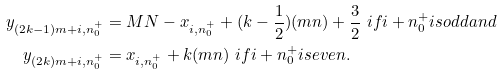<formula> <loc_0><loc_0><loc_500><loc_500>y _ { ( 2 k - 1 ) m + i , n ^ { + } _ { 0 } } & = M N - x _ { i , n ^ { + } _ { 0 } } + ( k - \frac { 1 } { 2 } ) ( m n ) + \frac { 3 } { 2 } \ i f i + n ^ { + } _ { 0 } i s o d d a n d \\ y _ { ( 2 k ) m + i , n ^ { + } _ { 0 } } & = x _ { i , n ^ { + } _ { 0 } } + k ( m n ) \ i f i + n ^ { + } _ { 0 } i s e v e n .</formula> 